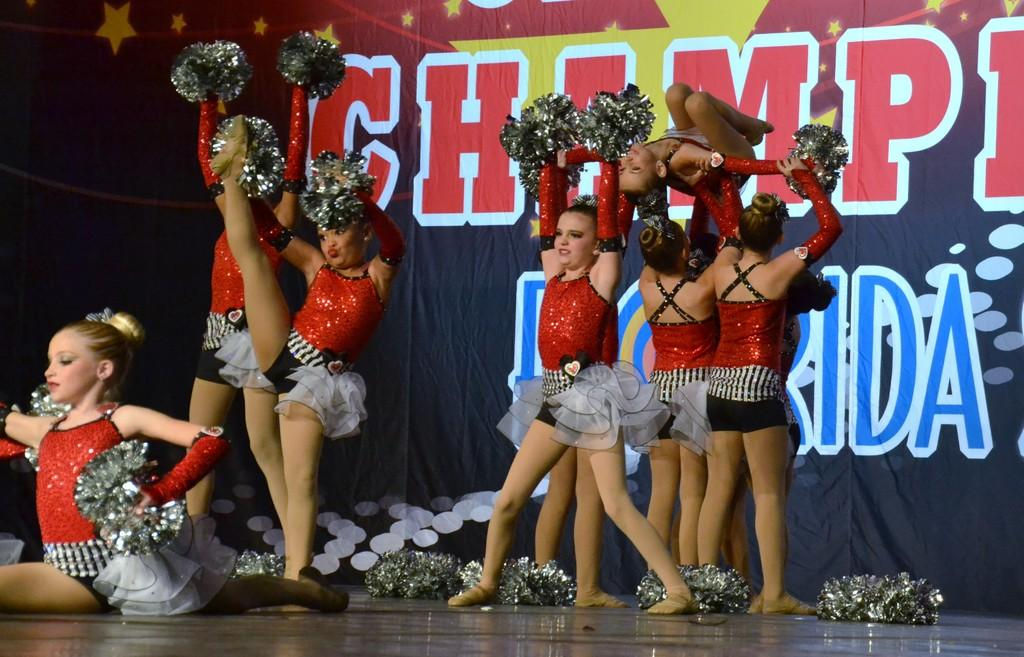What is happening to the woman in the image? There are people lifting a woman in the image. What can be seen in the background of the image? There is a hoarding in the background of the image. What is written on the hoarding? There is writing on the hoarding. What is on the floor in the image? There are objects on the floor in the image. What are the girls holding in the image? There are girls holding objects in the image. What type of reward is the woman receiving for her performance in the image? There is no indication in the image that the woman is receiving a reward for any performance. What type of celery can be seen growing in the image? There is no celery present in the image. 